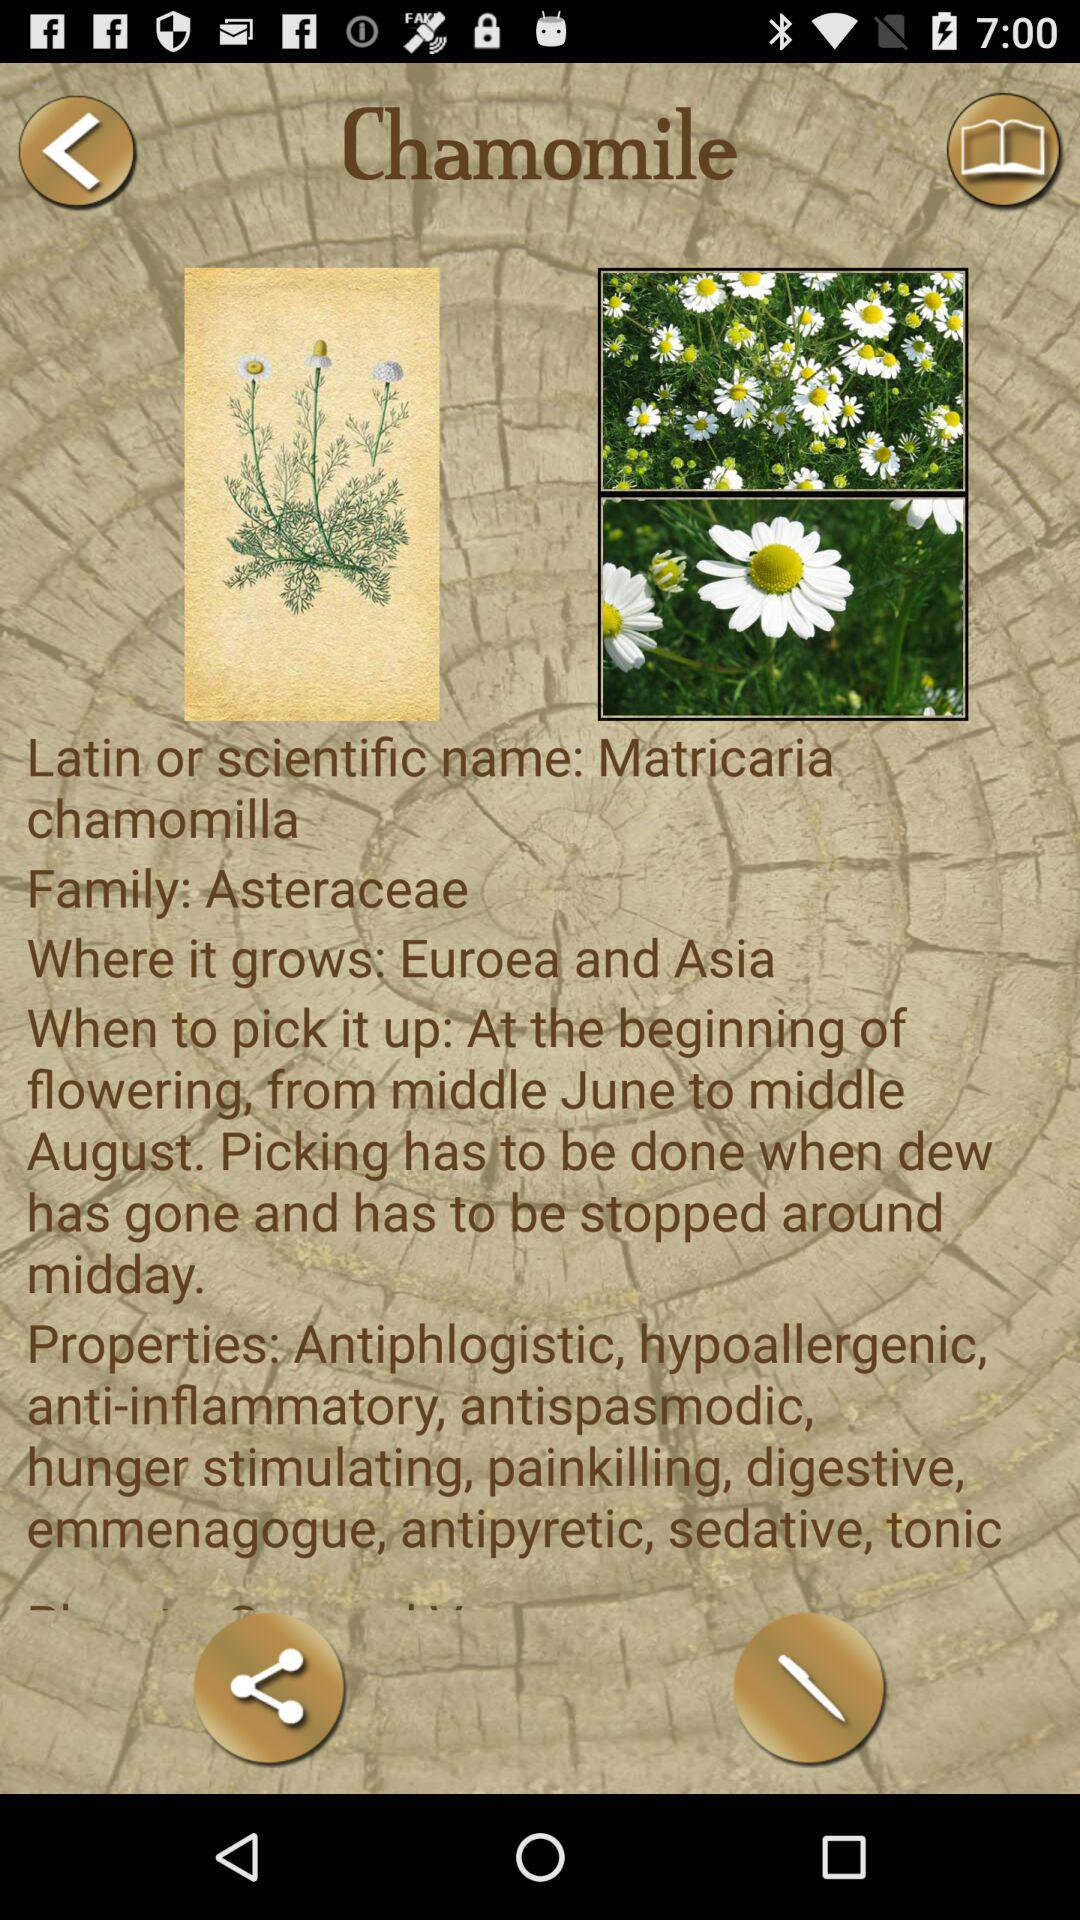What family belongs to the chamomile flower? The chamomile flower belongs to the Asteraceae family. 